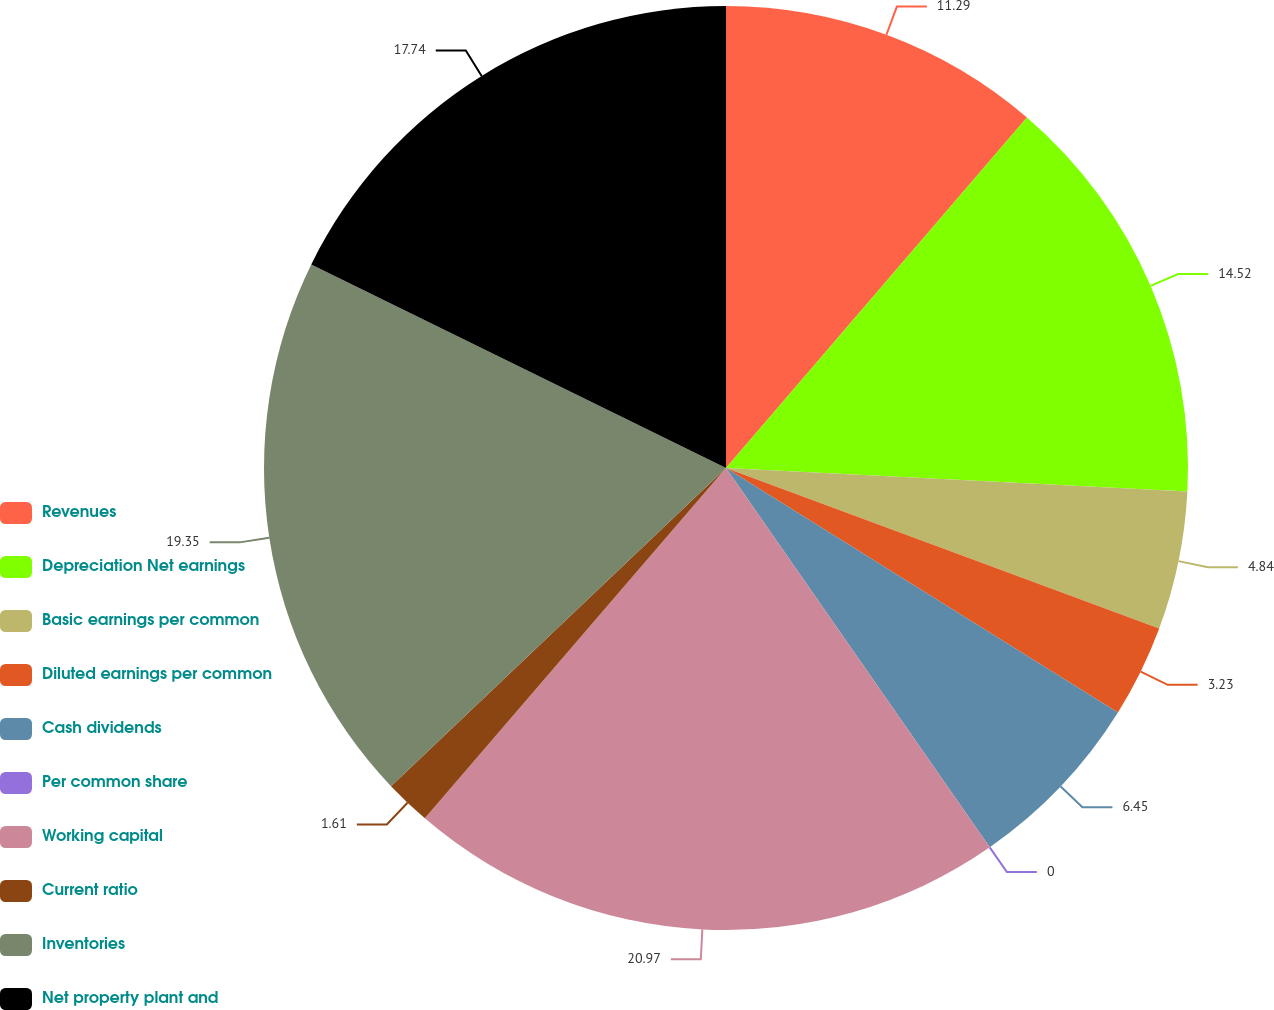Convert chart to OTSL. <chart><loc_0><loc_0><loc_500><loc_500><pie_chart><fcel>Revenues<fcel>Depreciation Net earnings<fcel>Basic earnings per common<fcel>Diluted earnings per common<fcel>Cash dividends<fcel>Per common share<fcel>Working capital<fcel>Current ratio<fcel>Inventories<fcel>Net property plant and<nl><fcel>11.29%<fcel>14.52%<fcel>4.84%<fcel>3.23%<fcel>6.45%<fcel>0.0%<fcel>20.97%<fcel>1.61%<fcel>19.35%<fcel>17.74%<nl></chart> 